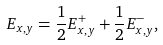Convert formula to latex. <formula><loc_0><loc_0><loc_500><loc_500>E _ { x , y } = \frac { 1 } { 2 } E _ { x , y } ^ { + } + \frac { 1 } { 2 } E _ { x , y } ^ { - } ,</formula> 